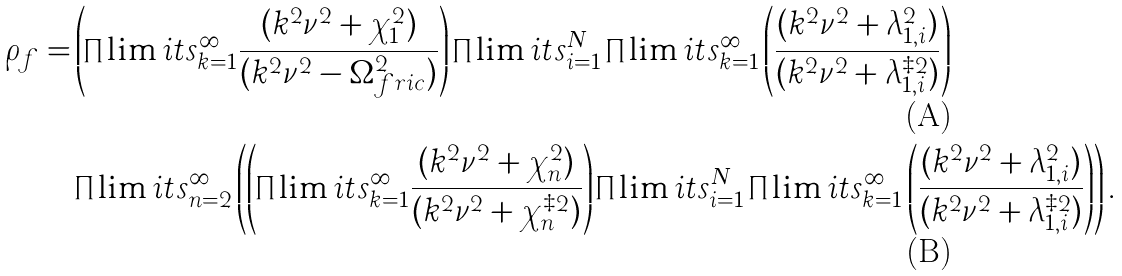Convert formula to latex. <formula><loc_0><loc_0><loc_500><loc_500>\rho _ { f } = & \left ( \prod \lim i t s _ { k = 1 } ^ { \infty } \frac { ( k ^ { 2 } \nu ^ { 2 } + \chi _ { 1 } ^ { 2 } ) } { ( k ^ { 2 } \nu ^ { 2 } - \Omega ^ { 2 } _ { f r i c } ) } \right ) \prod \lim i t s _ { i = 1 } ^ { N } \prod \lim i t s _ { k = 1 } ^ { \infty } \left ( \frac { ( k ^ { 2 } \nu ^ { 2 } + \lambda _ { 1 , i } ^ { 2 } ) } { ( k ^ { 2 } \nu ^ { 2 } + \lambda _ { 1 , i } ^ { \ddagger 2 } ) } \right ) \\ & \prod \lim i t s _ { n = 2 } ^ { \infty } \left ( \left ( \prod \lim i t s _ { k = 1 } ^ { \infty } \frac { ( k ^ { 2 } \nu ^ { 2 } + \chi _ { n } ^ { 2 } ) } { ( k ^ { 2 } \nu ^ { 2 } + \chi _ { n } ^ { \ddagger 2 } ) } \right ) \prod \lim i t s _ { i = 1 } ^ { N } \prod \lim i t s _ { k = 1 } ^ { \infty } \left ( \frac { ( k ^ { 2 } \nu ^ { 2 } + \lambda _ { 1 , i } ^ { 2 } ) } { ( k ^ { 2 } \nu ^ { 2 } + \lambda _ { 1 , i } ^ { \ddagger 2 } ) } \right ) \right ) .</formula> 